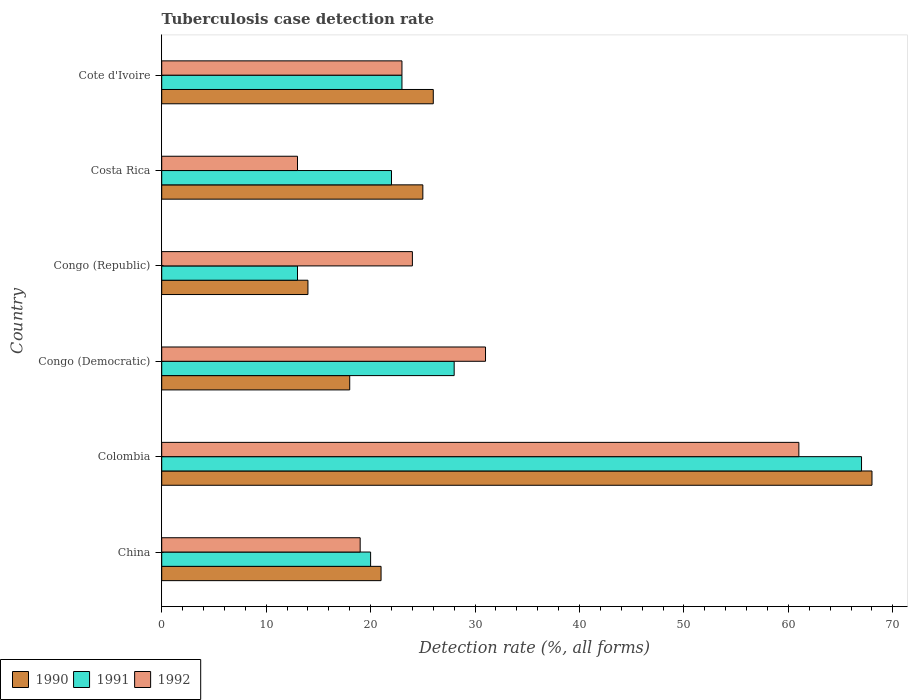How many different coloured bars are there?
Keep it short and to the point. 3. How many groups of bars are there?
Your response must be concise. 6. Are the number of bars per tick equal to the number of legend labels?
Your response must be concise. Yes. How many bars are there on the 4th tick from the top?
Your answer should be very brief. 3. How many bars are there on the 5th tick from the bottom?
Your response must be concise. 3. What is the label of the 2nd group of bars from the top?
Offer a terse response. Costa Rica. Across all countries, what is the maximum tuberculosis case detection rate in in 1992?
Give a very brief answer. 61. Across all countries, what is the minimum tuberculosis case detection rate in in 1990?
Your response must be concise. 14. In which country was the tuberculosis case detection rate in in 1991 minimum?
Ensure brevity in your answer.  Congo (Republic). What is the total tuberculosis case detection rate in in 1992 in the graph?
Ensure brevity in your answer.  171. What is the difference between the tuberculosis case detection rate in in 1992 in Colombia and that in Costa Rica?
Your answer should be very brief. 48. What is the difference between the tuberculosis case detection rate in in 1992 in Cote d'Ivoire and the tuberculosis case detection rate in in 1991 in Costa Rica?
Offer a terse response. 1. What is the average tuberculosis case detection rate in in 1991 per country?
Ensure brevity in your answer.  28.83. In how many countries, is the tuberculosis case detection rate in in 1992 greater than 14 %?
Your answer should be very brief. 5. What is the ratio of the tuberculosis case detection rate in in 1992 in Colombia to that in Congo (Democratic)?
Make the answer very short. 1.97. Is the tuberculosis case detection rate in in 1991 in Congo (Democratic) less than that in Cote d'Ivoire?
Provide a succinct answer. No. Is the difference between the tuberculosis case detection rate in in 1991 in Colombia and Congo (Republic) greater than the difference between the tuberculosis case detection rate in in 1992 in Colombia and Congo (Republic)?
Your answer should be compact. Yes. What is the difference between the highest and the lowest tuberculosis case detection rate in in 1990?
Give a very brief answer. 54. In how many countries, is the tuberculosis case detection rate in in 1990 greater than the average tuberculosis case detection rate in in 1990 taken over all countries?
Provide a succinct answer. 1. Is the sum of the tuberculosis case detection rate in in 1990 in China and Congo (Republic) greater than the maximum tuberculosis case detection rate in in 1992 across all countries?
Keep it short and to the point. No. Is it the case that in every country, the sum of the tuberculosis case detection rate in in 1990 and tuberculosis case detection rate in in 1992 is greater than the tuberculosis case detection rate in in 1991?
Your answer should be compact. Yes. How many bars are there?
Your answer should be compact. 18. Are all the bars in the graph horizontal?
Provide a short and direct response. Yes. Are the values on the major ticks of X-axis written in scientific E-notation?
Make the answer very short. No. Does the graph contain grids?
Make the answer very short. No. Where does the legend appear in the graph?
Offer a terse response. Bottom left. How many legend labels are there?
Your answer should be very brief. 3. How are the legend labels stacked?
Provide a succinct answer. Horizontal. What is the title of the graph?
Provide a succinct answer. Tuberculosis case detection rate. What is the label or title of the X-axis?
Your answer should be very brief. Detection rate (%, all forms). What is the Detection rate (%, all forms) in 1991 in China?
Provide a succinct answer. 20. What is the Detection rate (%, all forms) of 1992 in China?
Your response must be concise. 19. What is the Detection rate (%, all forms) in 1991 in Colombia?
Offer a very short reply. 67. What is the Detection rate (%, all forms) of 1992 in Colombia?
Give a very brief answer. 61. What is the Detection rate (%, all forms) in 1990 in Congo (Democratic)?
Your response must be concise. 18. What is the Detection rate (%, all forms) in 1992 in Costa Rica?
Offer a very short reply. 13. Across all countries, what is the minimum Detection rate (%, all forms) in 1990?
Offer a terse response. 14. Across all countries, what is the minimum Detection rate (%, all forms) in 1991?
Your response must be concise. 13. What is the total Detection rate (%, all forms) in 1990 in the graph?
Provide a succinct answer. 172. What is the total Detection rate (%, all forms) in 1991 in the graph?
Provide a short and direct response. 173. What is the total Detection rate (%, all forms) of 1992 in the graph?
Provide a succinct answer. 171. What is the difference between the Detection rate (%, all forms) in 1990 in China and that in Colombia?
Offer a terse response. -47. What is the difference between the Detection rate (%, all forms) of 1991 in China and that in Colombia?
Your answer should be compact. -47. What is the difference between the Detection rate (%, all forms) in 1992 in China and that in Colombia?
Offer a very short reply. -42. What is the difference between the Detection rate (%, all forms) of 1990 in China and that in Congo (Democratic)?
Provide a short and direct response. 3. What is the difference between the Detection rate (%, all forms) in 1992 in China and that in Congo (Republic)?
Offer a very short reply. -5. What is the difference between the Detection rate (%, all forms) of 1991 in China and that in Costa Rica?
Offer a very short reply. -2. What is the difference between the Detection rate (%, all forms) of 1992 in China and that in Costa Rica?
Provide a short and direct response. 6. What is the difference between the Detection rate (%, all forms) in 1990 in China and that in Cote d'Ivoire?
Ensure brevity in your answer.  -5. What is the difference between the Detection rate (%, all forms) in 1991 in Colombia and that in Congo (Democratic)?
Make the answer very short. 39. What is the difference between the Detection rate (%, all forms) of 1992 in Colombia and that in Congo (Democratic)?
Keep it short and to the point. 30. What is the difference between the Detection rate (%, all forms) of 1990 in Colombia and that in Congo (Republic)?
Your answer should be compact. 54. What is the difference between the Detection rate (%, all forms) of 1992 in Colombia and that in Costa Rica?
Offer a very short reply. 48. What is the difference between the Detection rate (%, all forms) of 1991 in Colombia and that in Cote d'Ivoire?
Provide a short and direct response. 44. What is the difference between the Detection rate (%, all forms) of 1990 in Congo (Democratic) and that in Congo (Republic)?
Your answer should be compact. 4. What is the difference between the Detection rate (%, all forms) of 1991 in Congo (Democratic) and that in Congo (Republic)?
Ensure brevity in your answer.  15. What is the difference between the Detection rate (%, all forms) in 1991 in Congo (Democratic) and that in Costa Rica?
Provide a succinct answer. 6. What is the difference between the Detection rate (%, all forms) in 1990 in Congo (Democratic) and that in Cote d'Ivoire?
Provide a succinct answer. -8. What is the difference between the Detection rate (%, all forms) in 1990 in Congo (Republic) and that in Costa Rica?
Give a very brief answer. -11. What is the difference between the Detection rate (%, all forms) in 1991 in Congo (Republic) and that in Costa Rica?
Your answer should be compact. -9. What is the difference between the Detection rate (%, all forms) in 1992 in Congo (Republic) and that in Costa Rica?
Ensure brevity in your answer.  11. What is the difference between the Detection rate (%, all forms) in 1991 in Congo (Republic) and that in Cote d'Ivoire?
Your response must be concise. -10. What is the difference between the Detection rate (%, all forms) of 1992 in Costa Rica and that in Cote d'Ivoire?
Ensure brevity in your answer.  -10. What is the difference between the Detection rate (%, all forms) in 1990 in China and the Detection rate (%, all forms) in 1991 in Colombia?
Your response must be concise. -46. What is the difference between the Detection rate (%, all forms) in 1991 in China and the Detection rate (%, all forms) in 1992 in Colombia?
Give a very brief answer. -41. What is the difference between the Detection rate (%, all forms) of 1990 in China and the Detection rate (%, all forms) of 1991 in Congo (Democratic)?
Provide a short and direct response. -7. What is the difference between the Detection rate (%, all forms) in 1991 in China and the Detection rate (%, all forms) in 1992 in Congo (Democratic)?
Ensure brevity in your answer.  -11. What is the difference between the Detection rate (%, all forms) in 1990 in China and the Detection rate (%, all forms) in 1992 in Congo (Republic)?
Give a very brief answer. -3. What is the difference between the Detection rate (%, all forms) of 1991 in China and the Detection rate (%, all forms) of 1992 in Congo (Republic)?
Ensure brevity in your answer.  -4. What is the difference between the Detection rate (%, all forms) of 1990 in China and the Detection rate (%, all forms) of 1991 in Cote d'Ivoire?
Make the answer very short. -2. What is the difference between the Detection rate (%, all forms) in 1990 in China and the Detection rate (%, all forms) in 1992 in Cote d'Ivoire?
Your answer should be very brief. -2. What is the difference between the Detection rate (%, all forms) of 1990 in Colombia and the Detection rate (%, all forms) of 1991 in Congo (Democratic)?
Your answer should be very brief. 40. What is the difference between the Detection rate (%, all forms) of 1991 in Colombia and the Detection rate (%, all forms) of 1992 in Congo (Democratic)?
Keep it short and to the point. 36. What is the difference between the Detection rate (%, all forms) of 1990 in Colombia and the Detection rate (%, all forms) of 1992 in Costa Rica?
Ensure brevity in your answer.  55. What is the difference between the Detection rate (%, all forms) of 1990 in Colombia and the Detection rate (%, all forms) of 1991 in Cote d'Ivoire?
Your answer should be compact. 45. What is the difference between the Detection rate (%, all forms) of 1990 in Congo (Democratic) and the Detection rate (%, all forms) of 1992 in Congo (Republic)?
Provide a short and direct response. -6. What is the difference between the Detection rate (%, all forms) of 1990 in Congo (Democratic) and the Detection rate (%, all forms) of 1991 in Costa Rica?
Keep it short and to the point. -4. What is the difference between the Detection rate (%, all forms) of 1990 in Congo (Democratic) and the Detection rate (%, all forms) of 1992 in Costa Rica?
Offer a very short reply. 5. What is the difference between the Detection rate (%, all forms) of 1991 in Congo (Democratic) and the Detection rate (%, all forms) of 1992 in Costa Rica?
Your response must be concise. 15. What is the difference between the Detection rate (%, all forms) of 1990 in Congo (Democratic) and the Detection rate (%, all forms) of 1991 in Cote d'Ivoire?
Your answer should be compact. -5. What is the difference between the Detection rate (%, all forms) of 1990 in Congo (Democratic) and the Detection rate (%, all forms) of 1992 in Cote d'Ivoire?
Make the answer very short. -5. What is the difference between the Detection rate (%, all forms) in 1990 in Congo (Republic) and the Detection rate (%, all forms) in 1991 in Costa Rica?
Your answer should be compact. -8. What is the difference between the Detection rate (%, all forms) of 1990 in Congo (Republic) and the Detection rate (%, all forms) of 1991 in Cote d'Ivoire?
Ensure brevity in your answer.  -9. What is the difference between the Detection rate (%, all forms) of 1990 in Congo (Republic) and the Detection rate (%, all forms) of 1992 in Cote d'Ivoire?
Provide a short and direct response. -9. What is the difference between the Detection rate (%, all forms) in 1991 in Congo (Republic) and the Detection rate (%, all forms) in 1992 in Cote d'Ivoire?
Give a very brief answer. -10. What is the difference between the Detection rate (%, all forms) of 1990 in Costa Rica and the Detection rate (%, all forms) of 1992 in Cote d'Ivoire?
Your answer should be compact. 2. What is the average Detection rate (%, all forms) in 1990 per country?
Ensure brevity in your answer.  28.67. What is the average Detection rate (%, all forms) of 1991 per country?
Offer a very short reply. 28.83. What is the average Detection rate (%, all forms) of 1992 per country?
Offer a very short reply. 28.5. What is the difference between the Detection rate (%, all forms) of 1990 and Detection rate (%, all forms) of 1992 in China?
Make the answer very short. 2. What is the difference between the Detection rate (%, all forms) of 1991 and Detection rate (%, all forms) of 1992 in China?
Your answer should be compact. 1. What is the difference between the Detection rate (%, all forms) of 1990 and Detection rate (%, all forms) of 1992 in Colombia?
Your answer should be compact. 7. What is the difference between the Detection rate (%, all forms) in 1991 and Detection rate (%, all forms) in 1992 in Colombia?
Offer a very short reply. 6. What is the difference between the Detection rate (%, all forms) of 1990 and Detection rate (%, all forms) of 1991 in Congo (Democratic)?
Give a very brief answer. -10. What is the difference between the Detection rate (%, all forms) in 1990 and Detection rate (%, all forms) in 1992 in Congo (Democratic)?
Provide a short and direct response. -13. What is the difference between the Detection rate (%, all forms) of 1991 and Detection rate (%, all forms) of 1992 in Congo (Democratic)?
Keep it short and to the point. -3. What is the difference between the Detection rate (%, all forms) of 1991 and Detection rate (%, all forms) of 1992 in Congo (Republic)?
Offer a very short reply. -11. What is the difference between the Detection rate (%, all forms) in 1990 and Detection rate (%, all forms) in 1991 in Costa Rica?
Keep it short and to the point. 3. What is the difference between the Detection rate (%, all forms) of 1991 and Detection rate (%, all forms) of 1992 in Costa Rica?
Make the answer very short. 9. What is the difference between the Detection rate (%, all forms) of 1990 and Detection rate (%, all forms) of 1992 in Cote d'Ivoire?
Offer a terse response. 3. What is the difference between the Detection rate (%, all forms) of 1991 and Detection rate (%, all forms) of 1992 in Cote d'Ivoire?
Offer a very short reply. 0. What is the ratio of the Detection rate (%, all forms) of 1990 in China to that in Colombia?
Provide a short and direct response. 0.31. What is the ratio of the Detection rate (%, all forms) of 1991 in China to that in Colombia?
Ensure brevity in your answer.  0.3. What is the ratio of the Detection rate (%, all forms) in 1992 in China to that in Colombia?
Provide a succinct answer. 0.31. What is the ratio of the Detection rate (%, all forms) in 1991 in China to that in Congo (Democratic)?
Offer a terse response. 0.71. What is the ratio of the Detection rate (%, all forms) of 1992 in China to that in Congo (Democratic)?
Make the answer very short. 0.61. What is the ratio of the Detection rate (%, all forms) of 1990 in China to that in Congo (Republic)?
Offer a terse response. 1.5. What is the ratio of the Detection rate (%, all forms) of 1991 in China to that in Congo (Republic)?
Your response must be concise. 1.54. What is the ratio of the Detection rate (%, all forms) of 1992 in China to that in Congo (Republic)?
Provide a succinct answer. 0.79. What is the ratio of the Detection rate (%, all forms) of 1990 in China to that in Costa Rica?
Provide a succinct answer. 0.84. What is the ratio of the Detection rate (%, all forms) of 1992 in China to that in Costa Rica?
Give a very brief answer. 1.46. What is the ratio of the Detection rate (%, all forms) of 1990 in China to that in Cote d'Ivoire?
Make the answer very short. 0.81. What is the ratio of the Detection rate (%, all forms) of 1991 in China to that in Cote d'Ivoire?
Keep it short and to the point. 0.87. What is the ratio of the Detection rate (%, all forms) in 1992 in China to that in Cote d'Ivoire?
Provide a short and direct response. 0.83. What is the ratio of the Detection rate (%, all forms) of 1990 in Colombia to that in Congo (Democratic)?
Offer a terse response. 3.78. What is the ratio of the Detection rate (%, all forms) in 1991 in Colombia to that in Congo (Democratic)?
Your answer should be compact. 2.39. What is the ratio of the Detection rate (%, all forms) of 1992 in Colombia to that in Congo (Democratic)?
Ensure brevity in your answer.  1.97. What is the ratio of the Detection rate (%, all forms) of 1990 in Colombia to that in Congo (Republic)?
Give a very brief answer. 4.86. What is the ratio of the Detection rate (%, all forms) of 1991 in Colombia to that in Congo (Republic)?
Your response must be concise. 5.15. What is the ratio of the Detection rate (%, all forms) in 1992 in Colombia to that in Congo (Republic)?
Offer a terse response. 2.54. What is the ratio of the Detection rate (%, all forms) in 1990 in Colombia to that in Costa Rica?
Offer a terse response. 2.72. What is the ratio of the Detection rate (%, all forms) of 1991 in Colombia to that in Costa Rica?
Make the answer very short. 3.05. What is the ratio of the Detection rate (%, all forms) of 1992 in Colombia to that in Costa Rica?
Offer a terse response. 4.69. What is the ratio of the Detection rate (%, all forms) of 1990 in Colombia to that in Cote d'Ivoire?
Provide a short and direct response. 2.62. What is the ratio of the Detection rate (%, all forms) of 1991 in Colombia to that in Cote d'Ivoire?
Keep it short and to the point. 2.91. What is the ratio of the Detection rate (%, all forms) of 1992 in Colombia to that in Cote d'Ivoire?
Make the answer very short. 2.65. What is the ratio of the Detection rate (%, all forms) of 1991 in Congo (Democratic) to that in Congo (Republic)?
Ensure brevity in your answer.  2.15. What is the ratio of the Detection rate (%, all forms) in 1992 in Congo (Democratic) to that in Congo (Republic)?
Provide a succinct answer. 1.29. What is the ratio of the Detection rate (%, all forms) of 1990 in Congo (Democratic) to that in Costa Rica?
Offer a terse response. 0.72. What is the ratio of the Detection rate (%, all forms) in 1991 in Congo (Democratic) to that in Costa Rica?
Offer a terse response. 1.27. What is the ratio of the Detection rate (%, all forms) of 1992 in Congo (Democratic) to that in Costa Rica?
Offer a very short reply. 2.38. What is the ratio of the Detection rate (%, all forms) in 1990 in Congo (Democratic) to that in Cote d'Ivoire?
Keep it short and to the point. 0.69. What is the ratio of the Detection rate (%, all forms) in 1991 in Congo (Democratic) to that in Cote d'Ivoire?
Keep it short and to the point. 1.22. What is the ratio of the Detection rate (%, all forms) in 1992 in Congo (Democratic) to that in Cote d'Ivoire?
Your answer should be compact. 1.35. What is the ratio of the Detection rate (%, all forms) of 1990 in Congo (Republic) to that in Costa Rica?
Offer a very short reply. 0.56. What is the ratio of the Detection rate (%, all forms) in 1991 in Congo (Republic) to that in Costa Rica?
Offer a terse response. 0.59. What is the ratio of the Detection rate (%, all forms) in 1992 in Congo (Republic) to that in Costa Rica?
Your response must be concise. 1.85. What is the ratio of the Detection rate (%, all forms) of 1990 in Congo (Republic) to that in Cote d'Ivoire?
Your answer should be very brief. 0.54. What is the ratio of the Detection rate (%, all forms) in 1991 in Congo (Republic) to that in Cote d'Ivoire?
Offer a terse response. 0.57. What is the ratio of the Detection rate (%, all forms) of 1992 in Congo (Republic) to that in Cote d'Ivoire?
Give a very brief answer. 1.04. What is the ratio of the Detection rate (%, all forms) in 1990 in Costa Rica to that in Cote d'Ivoire?
Ensure brevity in your answer.  0.96. What is the ratio of the Detection rate (%, all forms) in 1991 in Costa Rica to that in Cote d'Ivoire?
Ensure brevity in your answer.  0.96. What is the ratio of the Detection rate (%, all forms) in 1992 in Costa Rica to that in Cote d'Ivoire?
Provide a short and direct response. 0.57. What is the difference between the highest and the second highest Detection rate (%, all forms) in 1990?
Make the answer very short. 42. What is the difference between the highest and the second highest Detection rate (%, all forms) in 1992?
Your answer should be very brief. 30. What is the difference between the highest and the lowest Detection rate (%, all forms) of 1992?
Your answer should be compact. 48. 